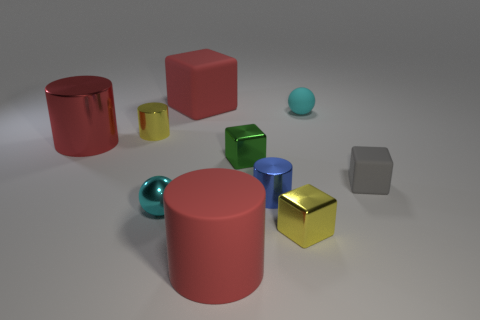Subtract all large cubes. How many cubes are left? 3 Subtract all gray blocks. How many blocks are left? 3 Subtract 2 balls. How many balls are left? 0 Subtract 1 yellow cylinders. How many objects are left? 9 Subtract all blocks. How many objects are left? 6 Subtract all blue blocks. Subtract all purple balls. How many blocks are left? 4 Subtract all brown blocks. How many red cylinders are left? 2 Subtract all cyan blocks. Subtract all tiny green things. How many objects are left? 9 Add 4 blocks. How many blocks are left? 8 Add 3 blue spheres. How many blue spheres exist? 3 